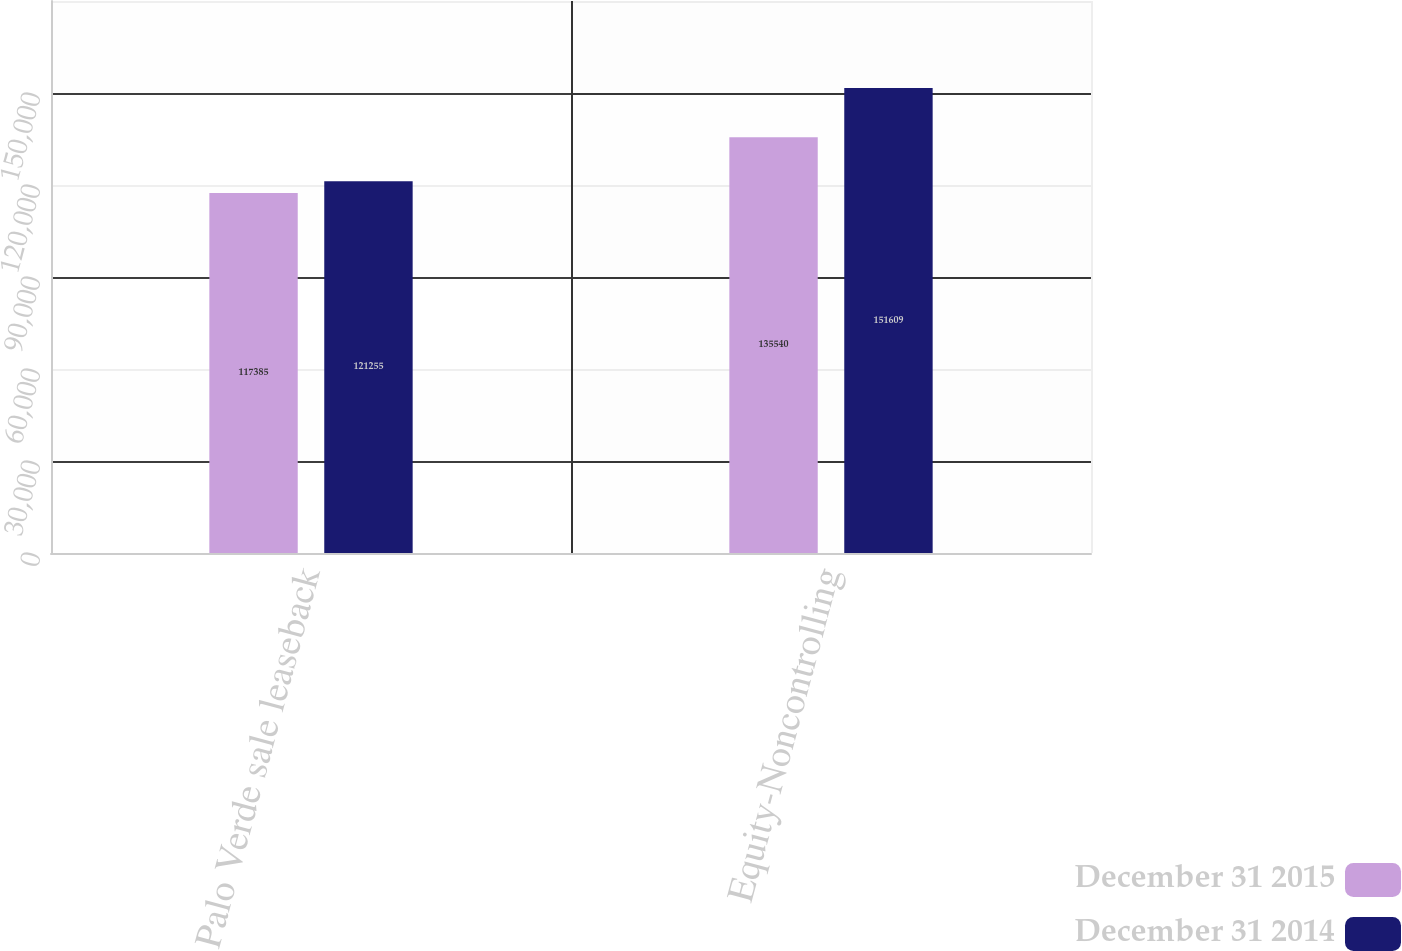Convert chart to OTSL. <chart><loc_0><loc_0><loc_500><loc_500><stacked_bar_chart><ecel><fcel>Palo Verde sale leaseback<fcel>Equity-Noncontrolling<nl><fcel>December 31 2015<fcel>117385<fcel>135540<nl><fcel>December 31 2014<fcel>121255<fcel>151609<nl></chart> 